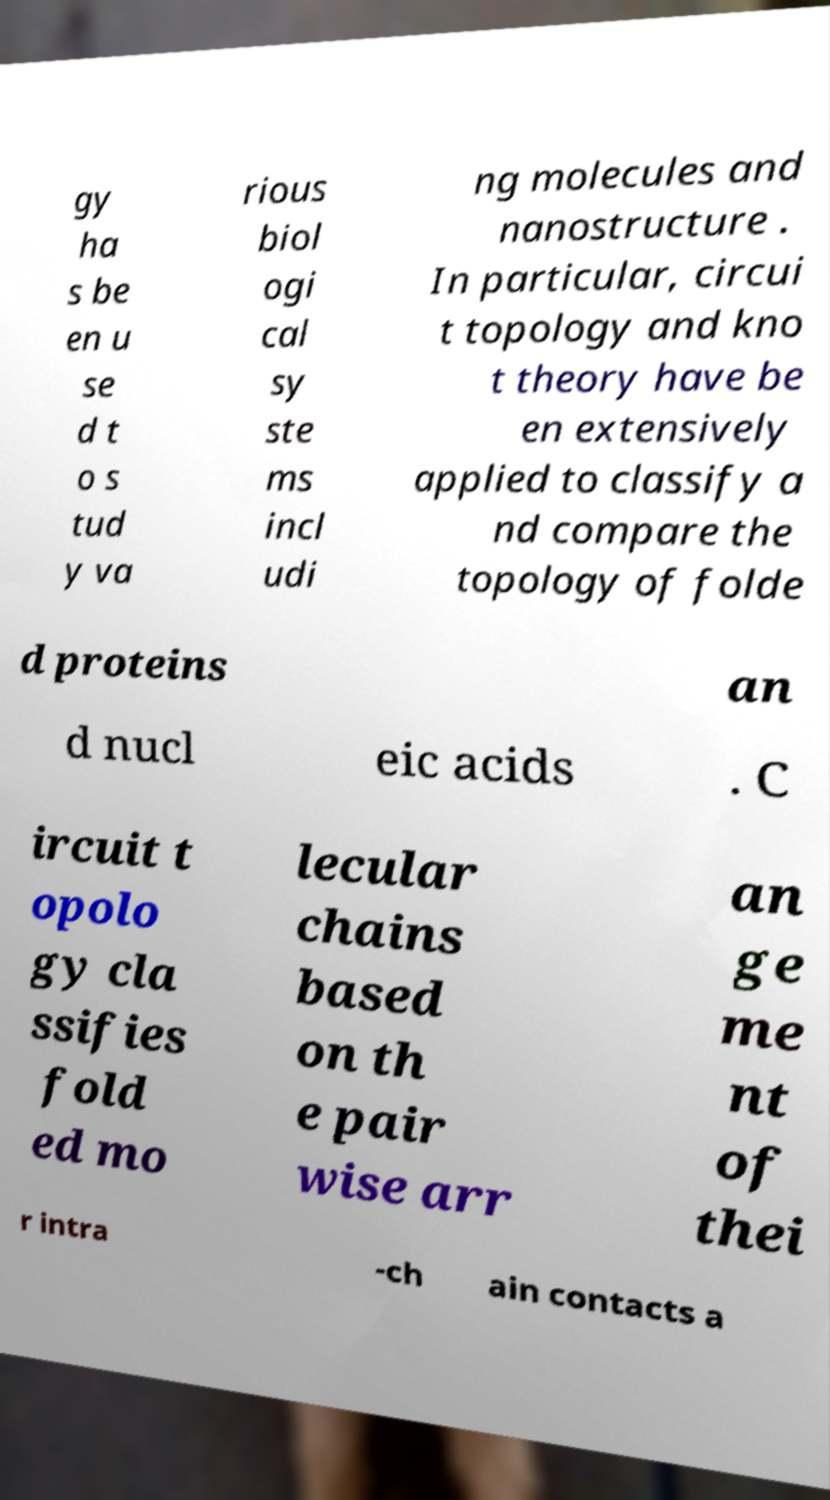I need the written content from this picture converted into text. Can you do that? gy ha s be en u se d t o s tud y va rious biol ogi cal sy ste ms incl udi ng molecules and nanostructure . In particular, circui t topology and kno t theory have be en extensively applied to classify a nd compare the topology of folde d proteins an d nucl eic acids . C ircuit t opolo gy cla ssifies fold ed mo lecular chains based on th e pair wise arr an ge me nt of thei r intra -ch ain contacts a 